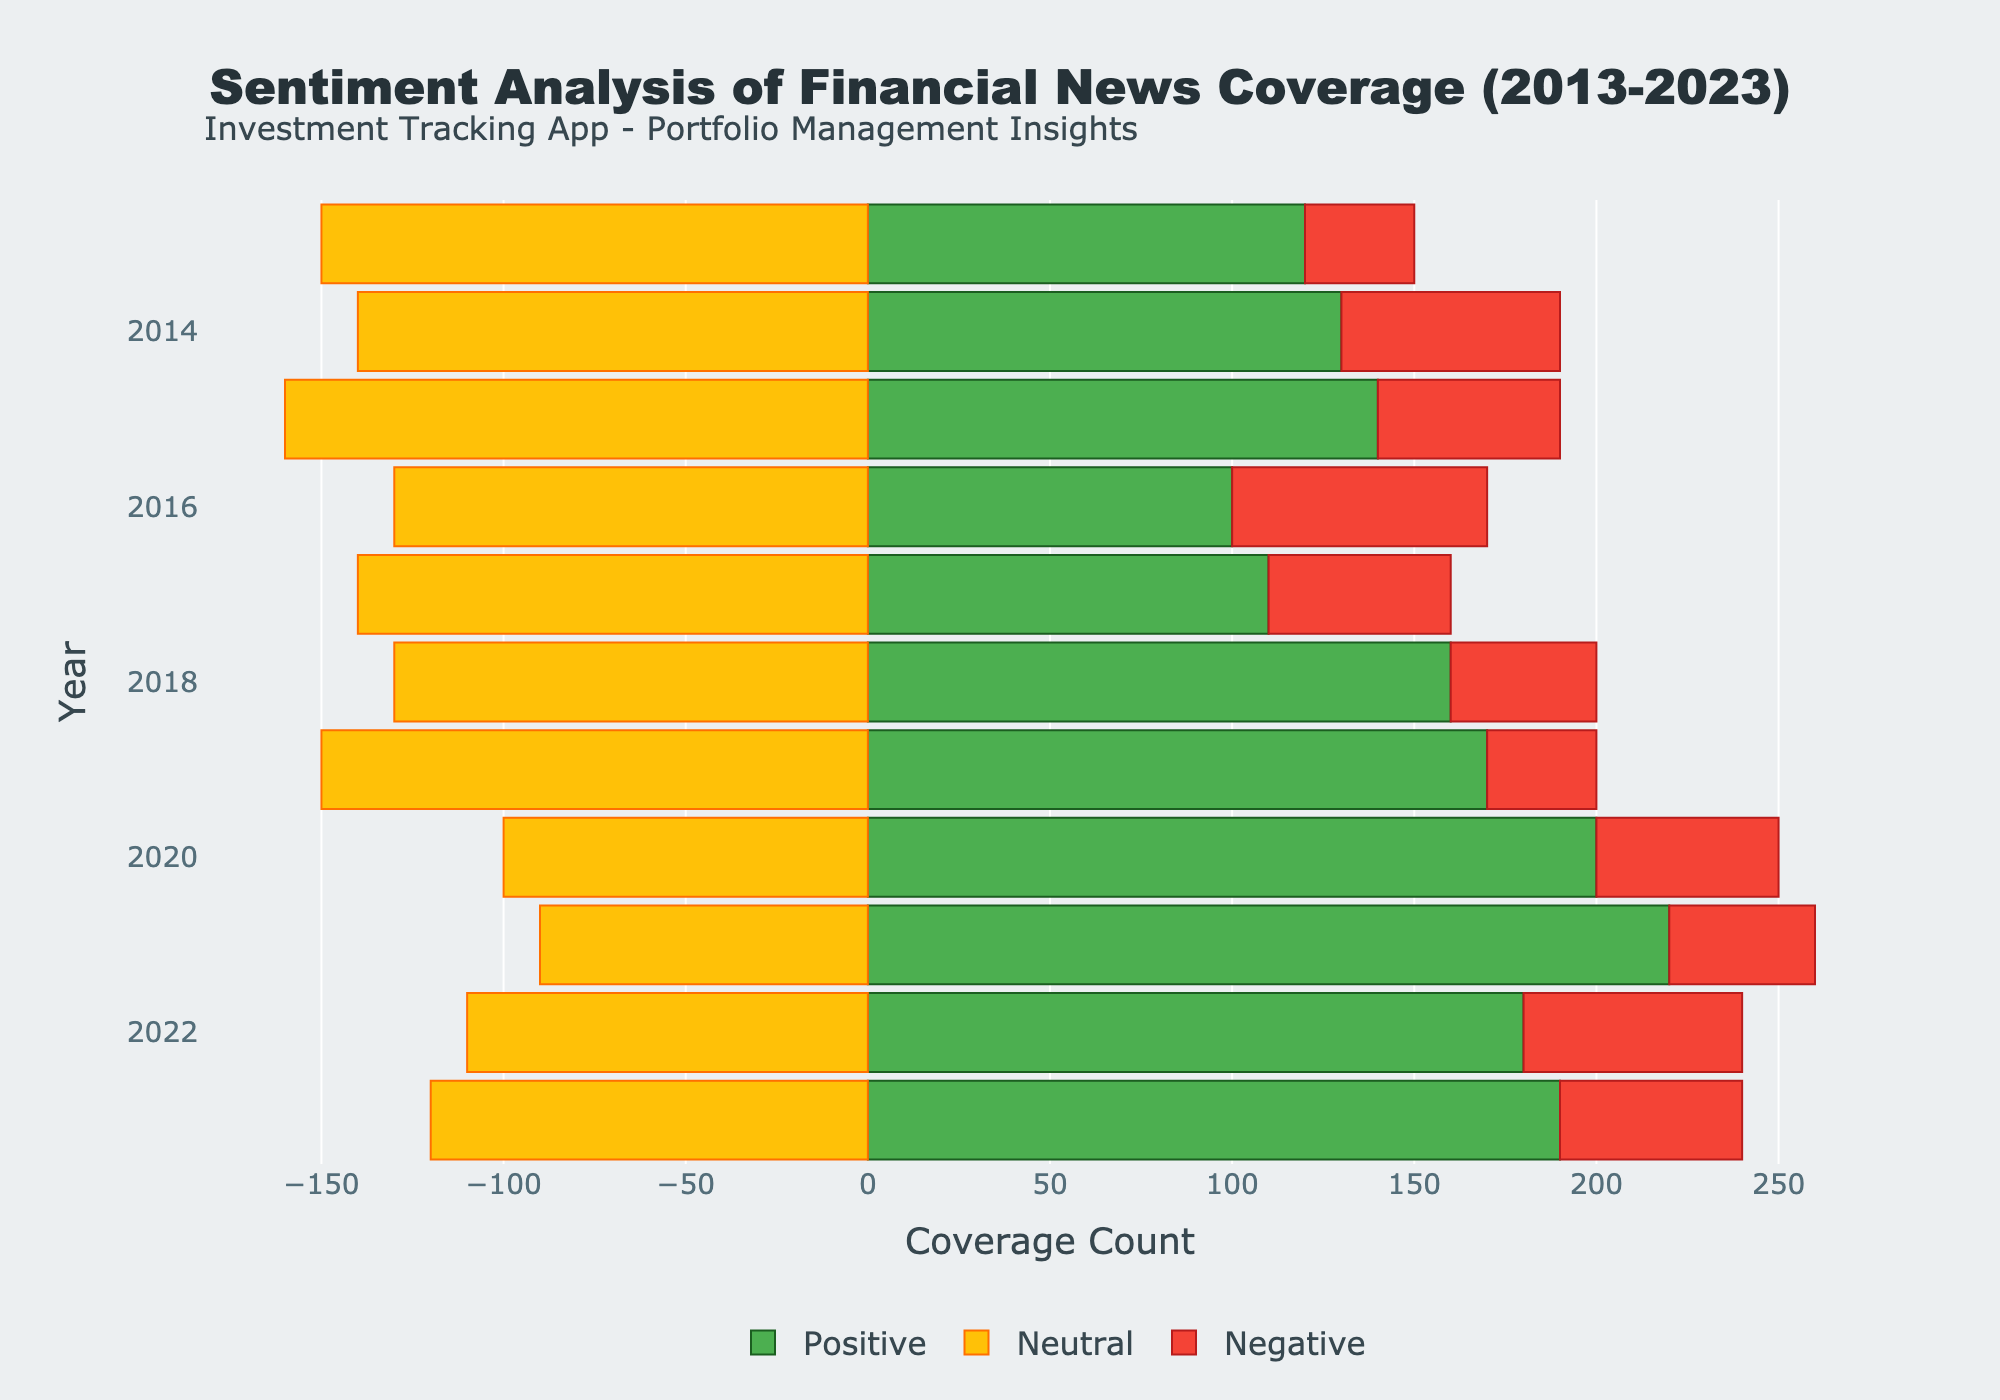Which year had the highest positive coverage of financial news? The highest positive coverage is shown by the longest green bar on the right side. For the year 2021, the green bar extends to 220 units, making it the highest.
Answer: 2021 What is the difference in positive coverage between 2018 and 2020? Check the green bars for 2018 and 2020. The positive coverage for 2018 is 160, and for 2020 it is 200. Calculate the difference: 200 - 160 = 40.
Answer: 40 Which year had the most neutral coverage, and what was the value? The neutral coverage is represented by the yellow bars extending to the left. The longest yellow bar corresponds to 2015 with a value of 160.
Answer: 2015, 160 Compare the negative coverage between 2014 and 2016. Which year had more negative coverage? Examine the red bars for 2014 and 2016. The red bar for 2014 extends to 60 units, while for 2016 it extends to 70 units. 2016 has more negative coverage.
Answer: 2016 In which year was the combined positive and negative coverage closest to the neutral coverage? For each year, sum the positive and negative coverages and compare with the neutral coverage (absolute value). For example, 2017 has positive 110 + negative 50 = 160, and neutral is 140. Repeat for each year to find the closest.
Answer: 2013 How did the positive and negative coverages change from 2019 to 2021? Compare the green and red bars for 2019, 2020, and 2021. Positive coverage increased from 170 in 2019 to 220 in 2021. Negative coverage was 30 in 2019 and it decreased to 40 by 2021. Positive coverage increased, while negative coverage fluctuated but was higher in 2021.
Answer: Positive increased, Negative fluctuated Which year had the smallest difference between positive and negative coverages? Calculate the difference between positive and negative coverages for each year and find the smallest difference. For example, for 2013 the difference is 120 - 30 = 90. Repeat for each year to find the minimum.
Answer: 2014 What is the average neutral coverage over the decade? Sum the neutral coverages for all years and divide by the number of years. Total sum = (150 - 140 - 160 - 130 - 140 - 130 - 150 - 100 - 90 - 110 - 120) = 1320. Average = 1320 / 11 = 120.
Answer: 120 Which year has the most balanced sentiment (similar values for positive, neutral, and negative)? Look for the year where green, yellow, and red bars are most similar in length. For example, 2016 has values 100, 130, and 70, which are comparatively balanced.
Answer: 2016 What was the total financial news coverage (sum of positive, neutral, and negative) in 2023? Add the coverages for 2023 (positive, neutral, and negative). Positive 190 + negative 50 = 240. For neutral, considering absolute value, it’s 120. Total = 190 + 120 + 50 = 360.
Answer: 360 